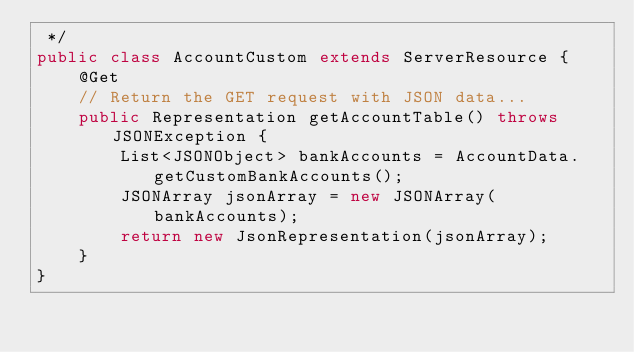Convert code to text. <code><loc_0><loc_0><loc_500><loc_500><_Java_> */
public class AccountCustom extends ServerResource {
    @Get
    // Return the GET request with JSON data...
    public Representation getAccountTable() throws JSONException {
    	List<JSONObject> bankAccounts = AccountData.getCustomBankAccounts();
    	JSONArray jsonArray = new JSONArray(bankAccounts);
        return new JsonRepresentation(jsonArray);
    }
}
</code> 